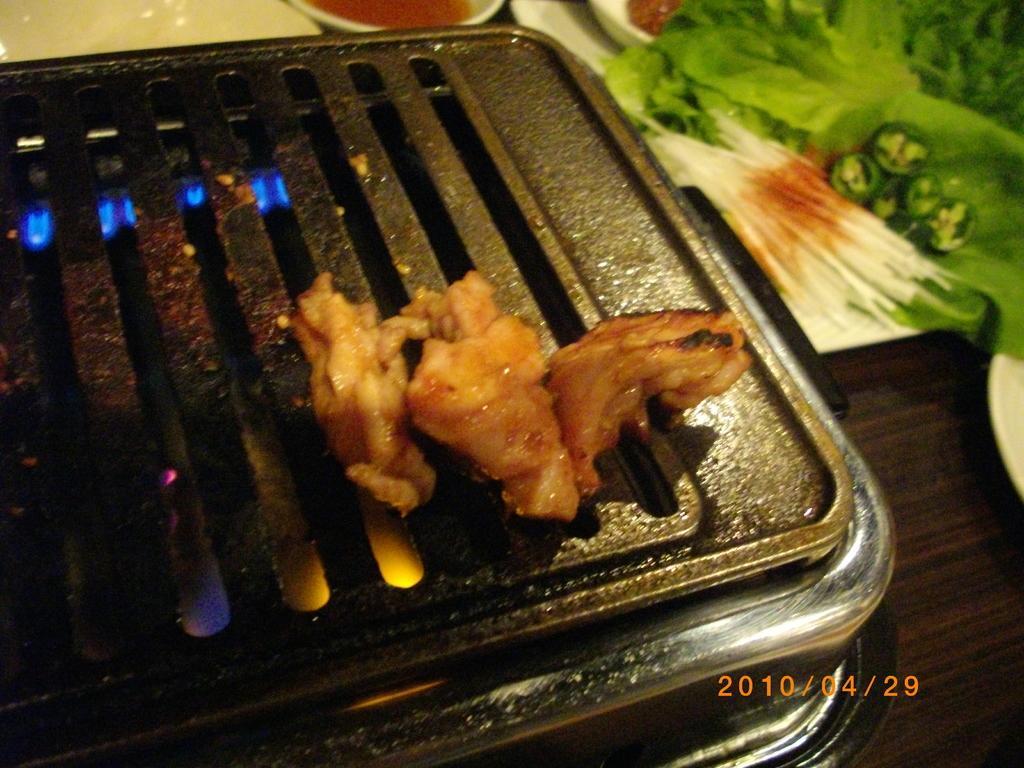Can you describe this image briefly? In the center of the image we can see a stove. On the stove food item is present. In the background of the image we can see some food items, a bowl of food item are present on the table. 